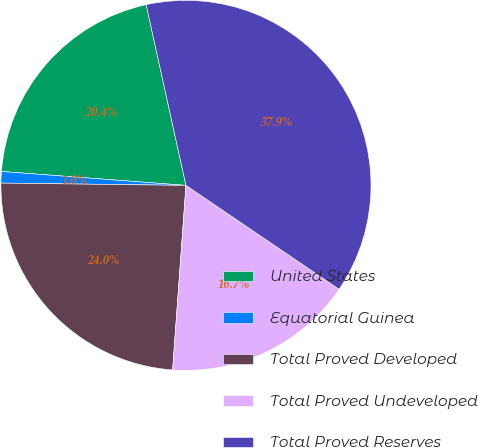Convert chart. <chart><loc_0><loc_0><loc_500><loc_500><pie_chart><fcel>United States<fcel>Equatorial Guinea<fcel>Total Proved Developed<fcel>Total Proved Undeveloped<fcel>Total Proved Reserves<nl><fcel>20.35%<fcel>1.0%<fcel>24.05%<fcel>16.66%<fcel>37.94%<nl></chart> 